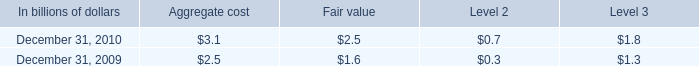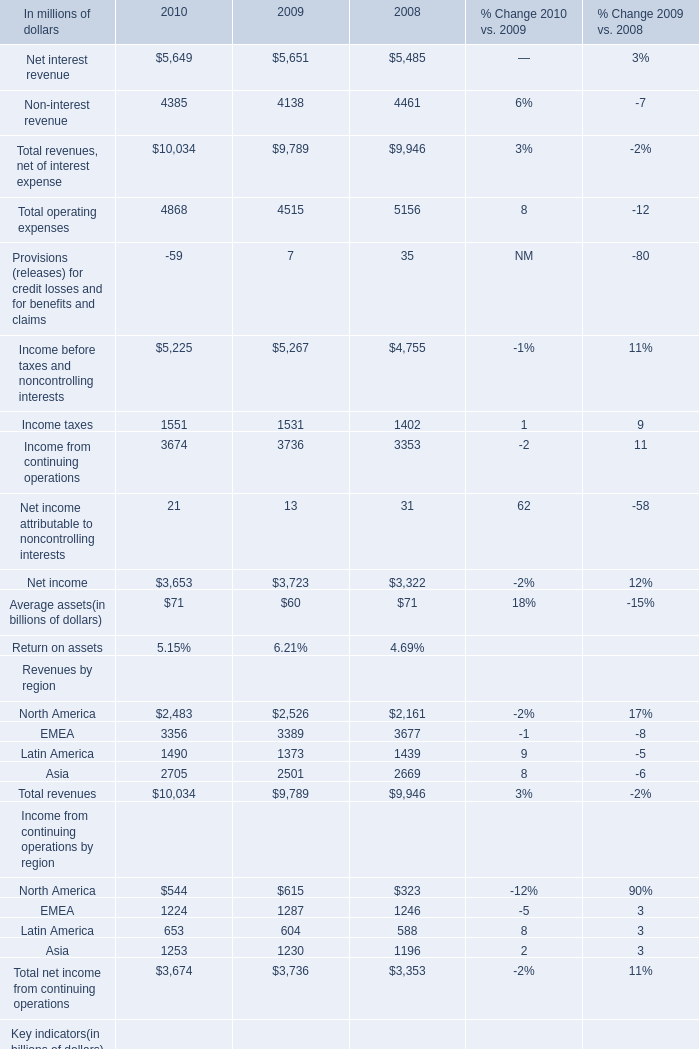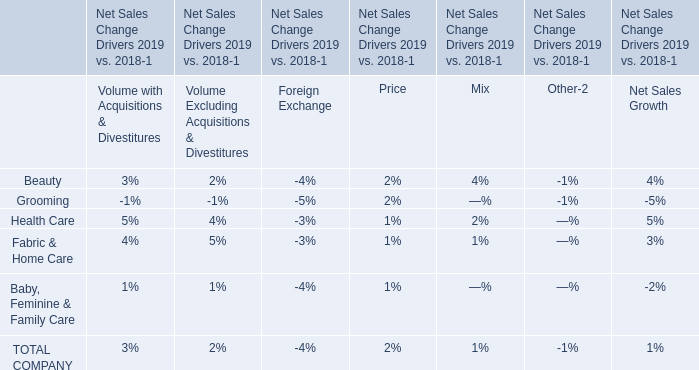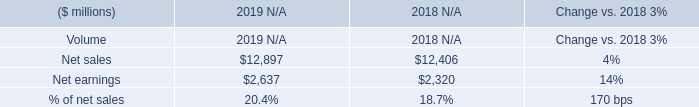what's the total amount of Income taxes of 2010, Net earnings of 2019 N/A, and Latin America Revenues by region of 2008 ? 
Computations: ((1551.0 + 2637.0) + 1439.0)
Answer: 5627.0. What was the total amount of North America, EMEA, Latin America and Asia in 2010 ? (in million) 
Computations: (10034 + 3674)
Answer: 13708.0. 